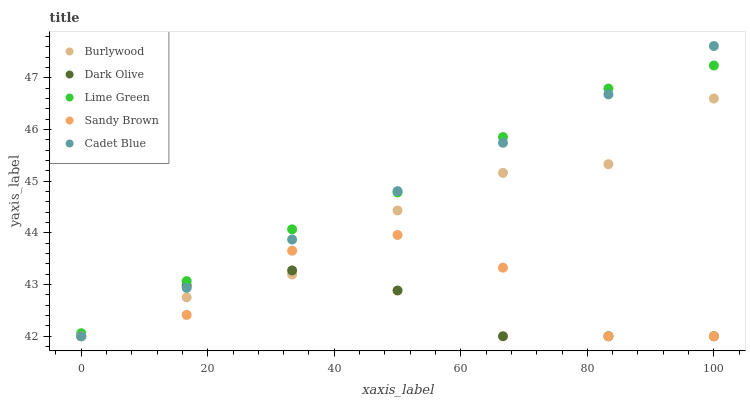Does Dark Olive have the minimum area under the curve?
Answer yes or no. Yes. Does Lime Green have the maximum area under the curve?
Answer yes or no. Yes. Does Sandy Brown have the minimum area under the curve?
Answer yes or no. No. Does Sandy Brown have the maximum area under the curve?
Answer yes or no. No. Is Cadet Blue the smoothest?
Answer yes or no. Yes. Is Sandy Brown the roughest?
Answer yes or no. Yes. Is Dark Olive the smoothest?
Answer yes or no. No. Is Dark Olive the roughest?
Answer yes or no. No. Does Burlywood have the lowest value?
Answer yes or no. Yes. Does Lime Green have the lowest value?
Answer yes or no. No. Does Cadet Blue have the highest value?
Answer yes or no. Yes. Does Sandy Brown have the highest value?
Answer yes or no. No. Is Sandy Brown less than Lime Green?
Answer yes or no. Yes. Is Lime Green greater than Dark Olive?
Answer yes or no. Yes. Does Lime Green intersect Cadet Blue?
Answer yes or no. Yes. Is Lime Green less than Cadet Blue?
Answer yes or no. No. Is Lime Green greater than Cadet Blue?
Answer yes or no. No. Does Sandy Brown intersect Lime Green?
Answer yes or no. No. 